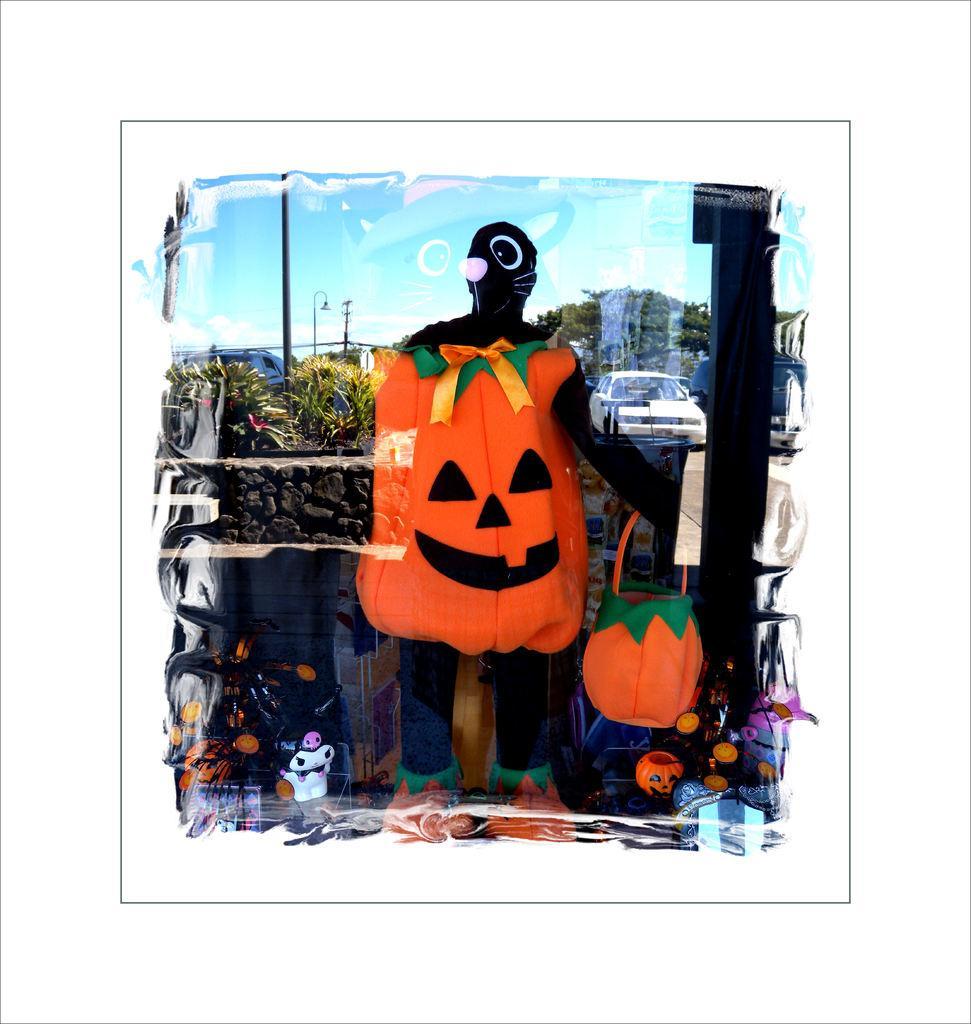Describe this image in one or two sentences. In the center of the image we can see a person holding a basket. In the background there are trees, cars, poles and sky. 